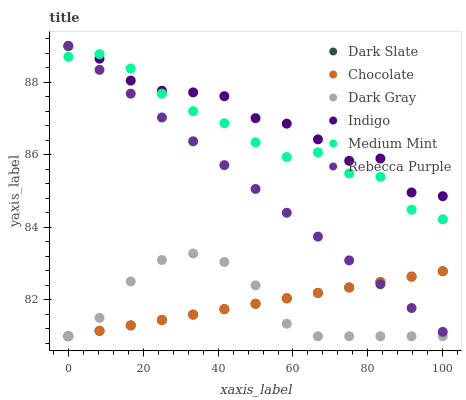Does Dark Gray have the minimum area under the curve?
Answer yes or no. Yes. Does Indigo have the maximum area under the curve?
Answer yes or no. Yes. Does Chocolate have the minimum area under the curve?
Answer yes or no. No. Does Chocolate have the maximum area under the curve?
Answer yes or no. No. Is Chocolate the smoothest?
Answer yes or no. Yes. Is Indigo the roughest?
Answer yes or no. Yes. Is Indigo the smoothest?
Answer yes or no. No. Is Chocolate the roughest?
Answer yes or no. No. Does Chocolate have the lowest value?
Answer yes or no. Yes. Does Indigo have the lowest value?
Answer yes or no. No. Does Rebecca Purple have the highest value?
Answer yes or no. Yes. Does Chocolate have the highest value?
Answer yes or no. No. Is Dark Gray less than Rebecca Purple?
Answer yes or no. Yes. Is Rebecca Purple greater than Dark Gray?
Answer yes or no. Yes. Does Rebecca Purple intersect Dark Slate?
Answer yes or no. Yes. Is Rebecca Purple less than Dark Slate?
Answer yes or no. No. Is Rebecca Purple greater than Dark Slate?
Answer yes or no. No. Does Dark Gray intersect Rebecca Purple?
Answer yes or no. No. 